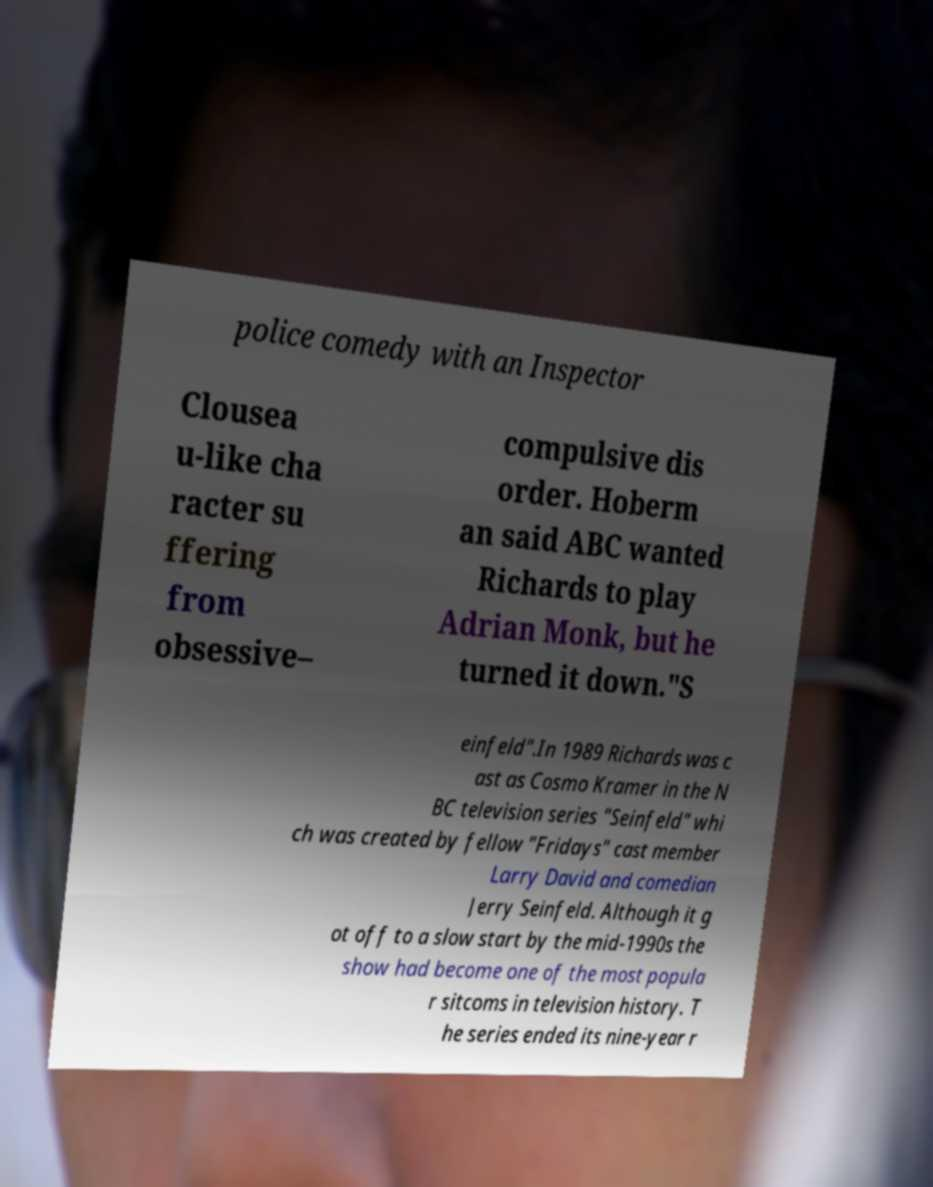I need the written content from this picture converted into text. Can you do that? police comedy with an Inspector Clousea u-like cha racter su ffering from obsessive– compulsive dis order. Hoberm an said ABC wanted Richards to play Adrian Monk, but he turned it down."S einfeld".In 1989 Richards was c ast as Cosmo Kramer in the N BC television series "Seinfeld" whi ch was created by fellow "Fridays" cast member Larry David and comedian Jerry Seinfeld. Although it g ot off to a slow start by the mid-1990s the show had become one of the most popula r sitcoms in television history. T he series ended its nine-year r 